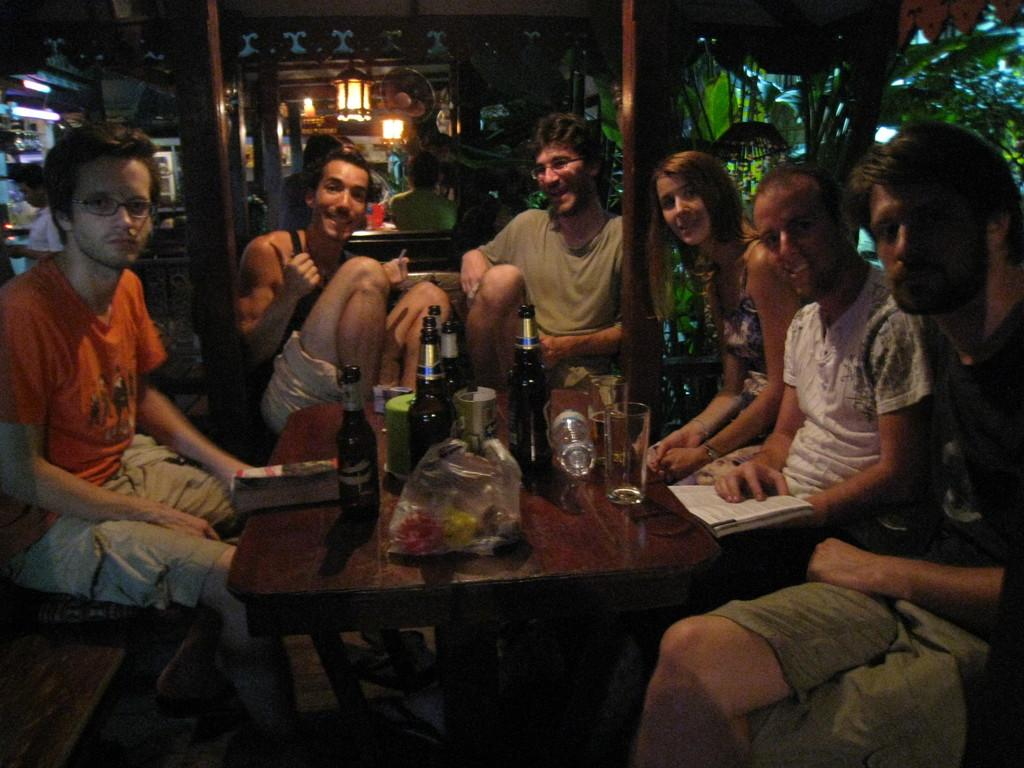What are the people in the image doing? The people in the image are sitting. What objects can be seen on the table in the image? There are bottles, glasses, and a book on the table. How many passengers are visible in the image? There are no passengers present in the image, as it features people sitting and objects on a table. What type of scale is used to weigh the objects on the table? There is no scale present in the image, as it only shows people sitting and objects on a table. 